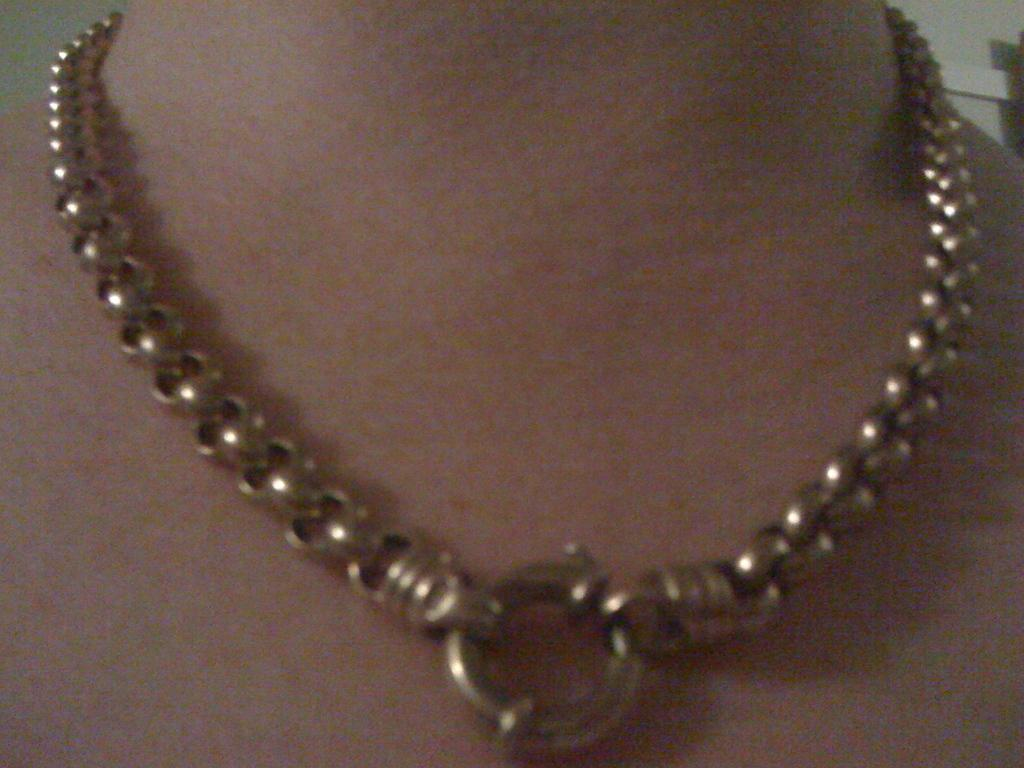What is present around the neck in the image? There is a chain on the neck in the image. Where is the chain located in relation to the rest of the image? The chain is located in the center of the image. How many pigs are visible in the image? There are no pigs present in the image. What emotion is being expressed by the chain in the image? The chain is an inanimate object and does not express emotions like hate. 